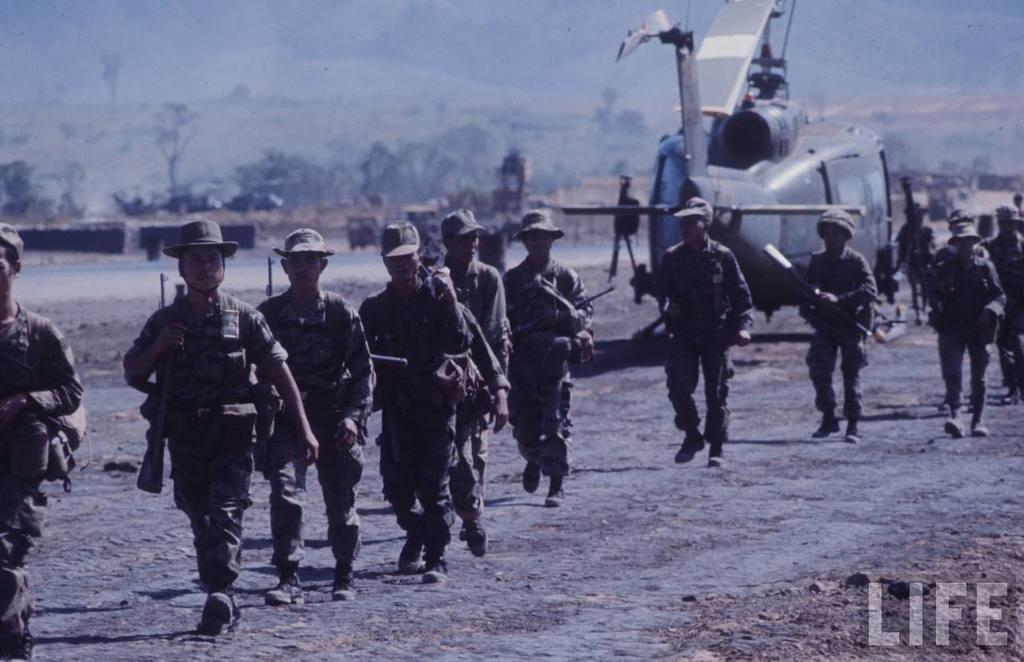Please provide a concise description of this image. In this picture we can see a group of people holding some objects and walking on the ground. Behind the people, there are vehicles, trees, hills, a helicopter and some objects. In the bottom right corner of the image, there is a watermark. 